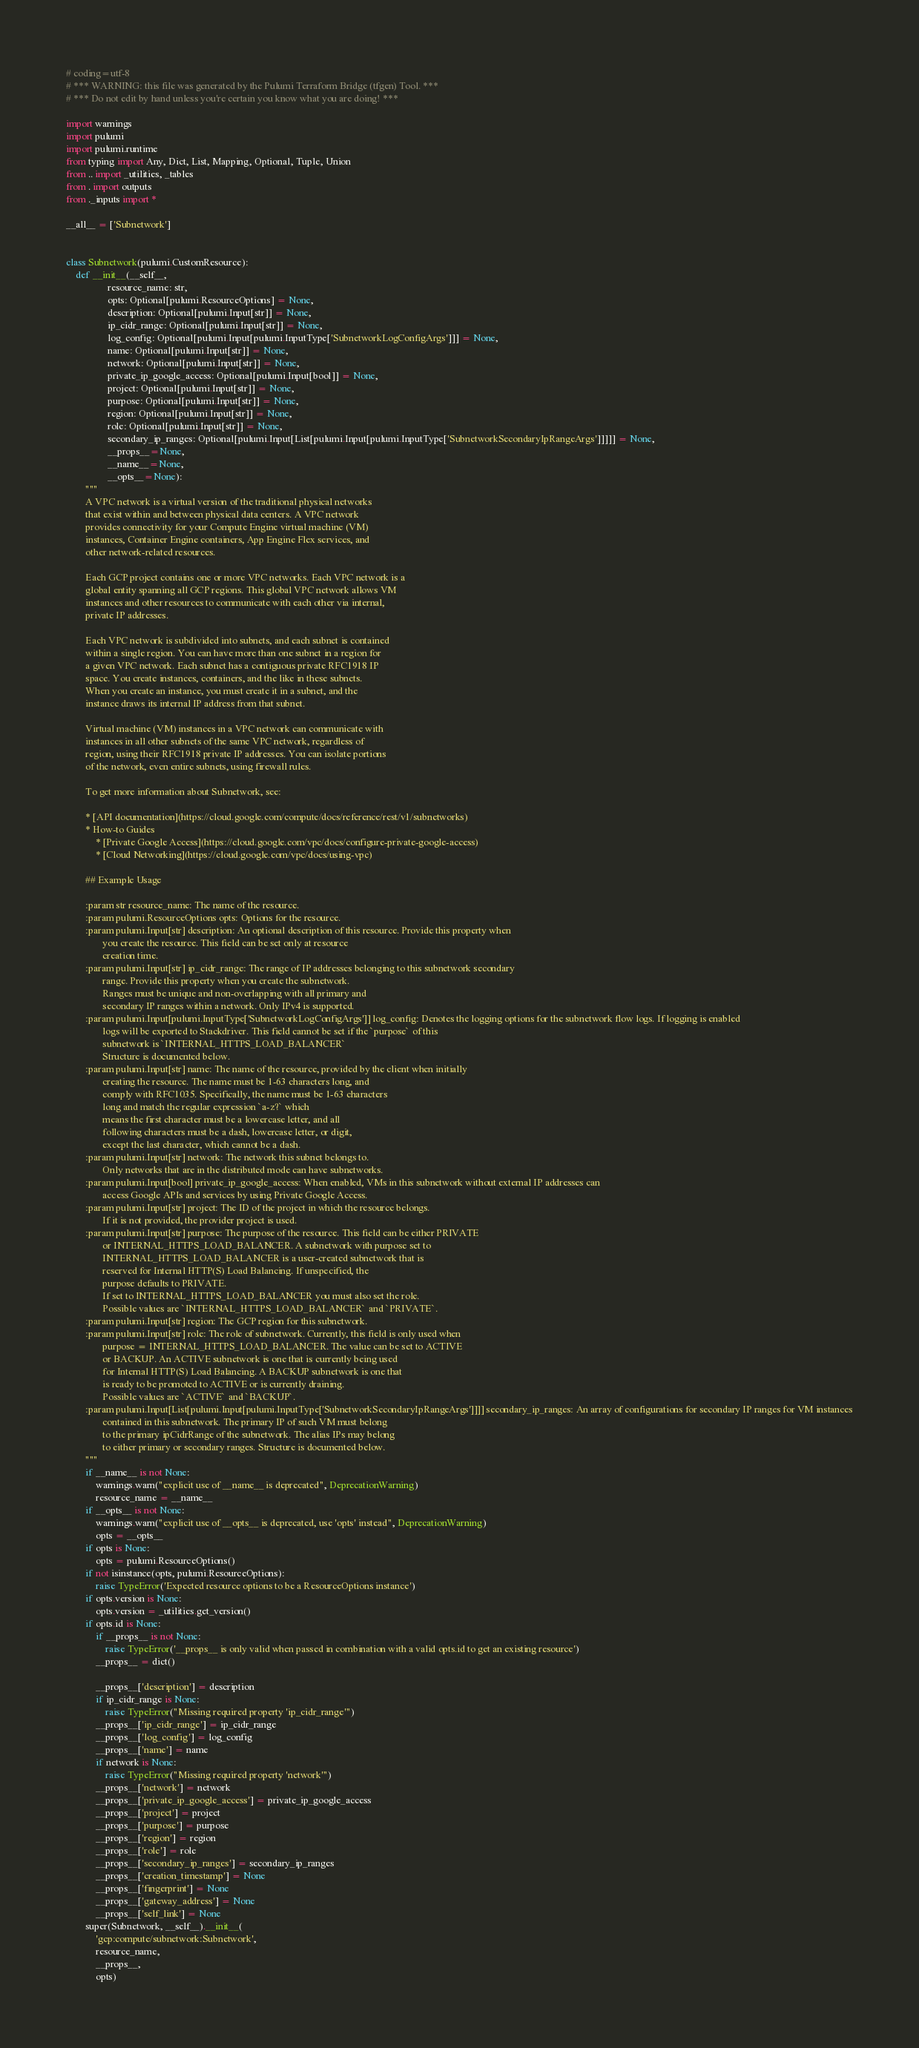Convert code to text. <code><loc_0><loc_0><loc_500><loc_500><_Python_># coding=utf-8
# *** WARNING: this file was generated by the Pulumi Terraform Bridge (tfgen) Tool. ***
# *** Do not edit by hand unless you're certain you know what you are doing! ***

import warnings
import pulumi
import pulumi.runtime
from typing import Any, Dict, List, Mapping, Optional, Tuple, Union
from .. import _utilities, _tables
from . import outputs
from ._inputs import *

__all__ = ['Subnetwork']


class Subnetwork(pulumi.CustomResource):
    def __init__(__self__,
                 resource_name: str,
                 opts: Optional[pulumi.ResourceOptions] = None,
                 description: Optional[pulumi.Input[str]] = None,
                 ip_cidr_range: Optional[pulumi.Input[str]] = None,
                 log_config: Optional[pulumi.Input[pulumi.InputType['SubnetworkLogConfigArgs']]] = None,
                 name: Optional[pulumi.Input[str]] = None,
                 network: Optional[pulumi.Input[str]] = None,
                 private_ip_google_access: Optional[pulumi.Input[bool]] = None,
                 project: Optional[pulumi.Input[str]] = None,
                 purpose: Optional[pulumi.Input[str]] = None,
                 region: Optional[pulumi.Input[str]] = None,
                 role: Optional[pulumi.Input[str]] = None,
                 secondary_ip_ranges: Optional[pulumi.Input[List[pulumi.Input[pulumi.InputType['SubnetworkSecondaryIpRangeArgs']]]]] = None,
                 __props__=None,
                 __name__=None,
                 __opts__=None):
        """
        A VPC network is a virtual version of the traditional physical networks
        that exist within and between physical data centers. A VPC network
        provides connectivity for your Compute Engine virtual machine (VM)
        instances, Container Engine containers, App Engine Flex services, and
        other network-related resources.

        Each GCP project contains one or more VPC networks. Each VPC network is a
        global entity spanning all GCP regions. This global VPC network allows VM
        instances and other resources to communicate with each other via internal,
        private IP addresses.

        Each VPC network is subdivided into subnets, and each subnet is contained
        within a single region. You can have more than one subnet in a region for
        a given VPC network. Each subnet has a contiguous private RFC1918 IP
        space. You create instances, containers, and the like in these subnets.
        When you create an instance, you must create it in a subnet, and the
        instance draws its internal IP address from that subnet.

        Virtual machine (VM) instances in a VPC network can communicate with
        instances in all other subnets of the same VPC network, regardless of
        region, using their RFC1918 private IP addresses. You can isolate portions
        of the network, even entire subnets, using firewall rules.

        To get more information about Subnetwork, see:

        * [API documentation](https://cloud.google.com/compute/docs/reference/rest/v1/subnetworks)
        * How-to Guides
            * [Private Google Access](https://cloud.google.com/vpc/docs/configure-private-google-access)
            * [Cloud Networking](https://cloud.google.com/vpc/docs/using-vpc)

        ## Example Usage

        :param str resource_name: The name of the resource.
        :param pulumi.ResourceOptions opts: Options for the resource.
        :param pulumi.Input[str] description: An optional description of this resource. Provide this property when
               you create the resource. This field can be set only at resource
               creation time.
        :param pulumi.Input[str] ip_cidr_range: The range of IP addresses belonging to this subnetwork secondary
               range. Provide this property when you create the subnetwork.
               Ranges must be unique and non-overlapping with all primary and
               secondary IP ranges within a network. Only IPv4 is supported.
        :param pulumi.Input[pulumi.InputType['SubnetworkLogConfigArgs']] log_config: Denotes the logging options for the subnetwork flow logs. If logging is enabled
               logs will be exported to Stackdriver. This field cannot be set if the `purpose` of this
               subnetwork is `INTERNAL_HTTPS_LOAD_BALANCER`
               Structure is documented below.
        :param pulumi.Input[str] name: The name of the resource, provided by the client when initially
               creating the resource. The name must be 1-63 characters long, and
               comply with RFC1035. Specifically, the name must be 1-63 characters
               long and match the regular expression `a-z?` which
               means the first character must be a lowercase letter, and all
               following characters must be a dash, lowercase letter, or digit,
               except the last character, which cannot be a dash.
        :param pulumi.Input[str] network: The network this subnet belongs to.
               Only networks that are in the distributed mode can have subnetworks.
        :param pulumi.Input[bool] private_ip_google_access: When enabled, VMs in this subnetwork without external IP addresses can
               access Google APIs and services by using Private Google Access.
        :param pulumi.Input[str] project: The ID of the project in which the resource belongs.
               If it is not provided, the provider project is used.
        :param pulumi.Input[str] purpose: The purpose of the resource. This field can be either PRIVATE
               or INTERNAL_HTTPS_LOAD_BALANCER. A subnetwork with purpose set to
               INTERNAL_HTTPS_LOAD_BALANCER is a user-created subnetwork that is
               reserved for Internal HTTP(S) Load Balancing. If unspecified, the
               purpose defaults to PRIVATE.
               If set to INTERNAL_HTTPS_LOAD_BALANCER you must also set the role.
               Possible values are `INTERNAL_HTTPS_LOAD_BALANCER` and `PRIVATE`.
        :param pulumi.Input[str] region: The GCP region for this subnetwork.
        :param pulumi.Input[str] role: The role of subnetwork. Currently, this field is only used when
               purpose = INTERNAL_HTTPS_LOAD_BALANCER. The value can be set to ACTIVE
               or BACKUP. An ACTIVE subnetwork is one that is currently being used
               for Internal HTTP(S) Load Balancing. A BACKUP subnetwork is one that
               is ready to be promoted to ACTIVE or is currently draining.
               Possible values are `ACTIVE` and `BACKUP`.
        :param pulumi.Input[List[pulumi.Input[pulumi.InputType['SubnetworkSecondaryIpRangeArgs']]]] secondary_ip_ranges: An array of configurations for secondary IP ranges for VM instances
               contained in this subnetwork. The primary IP of such VM must belong
               to the primary ipCidrRange of the subnetwork. The alias IPs may belong
               to either primary or secondary ranges. Structure is documented below.
        """
        if __name__ is not None:
            warnings.warn("explicit use of __name__ is deprecated", DeprecationWarning)
            resource_name = __name__
        if __opts__ is not None:
            warnings.warn("explicit use of __opts__ is deprecated, use 'opts' instead", DeprecationWarning)
            opts = __opts__
        if opts is None:
            opts = pulumi.ResourceOptions()
        if not isinstance(opts, pulumi.ResourceOptions):
            raise TypeError('Expected resource options to be a ResourceOptions instance')
        if opts.version is None:
            opts.version = _utilities.get_version()
        if opts.id is None:
            if __props__ is not None:
                raise TypeError('__props__ is only valid when passed in combination with a valid opts.id to get an existing resource')
            __props__ = dict()

            __props__['description'] = description
            if ip_cidr_range is None:
                raise TypeError("Missing required property 'ip_cidr_range'")
            __props__['ip_cidr_range'] = ip_cidr_range
            __props__['log_config'] = log_config
            __props__['name'] = name
            if network is None:
                raise TypeError("Missing required property 'network'")
            __props__['network'] = network
            __props__['private_ip_google_access'] = private_ip_google_access
            __props__['project'] = project
            __props__['purpose'] = purpose
            __props__['region'] = region
            __props__['role'] = role
            __props__['secondary_ip_ranges'] = secondary_ip_ranges
            __props__['creation_timestamp'] = None
            __props__['fingerprint'] = None
            __props__['gateway_address'] = None
            __props__['self_link'] = None
        super(Subnetwork, __self__).__init__(
            'gcp:compute/subnetwork:Subnetwork',
            resource_name,
            __props__,
            opts)
</code> 